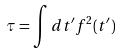Convert formula to latex. <formula><loc_0><loc_0><loc_500><loc_500>\tau = \int d t ^ { \prime } f ^ { 2 } ( t ^ { \prime } )</formula> 